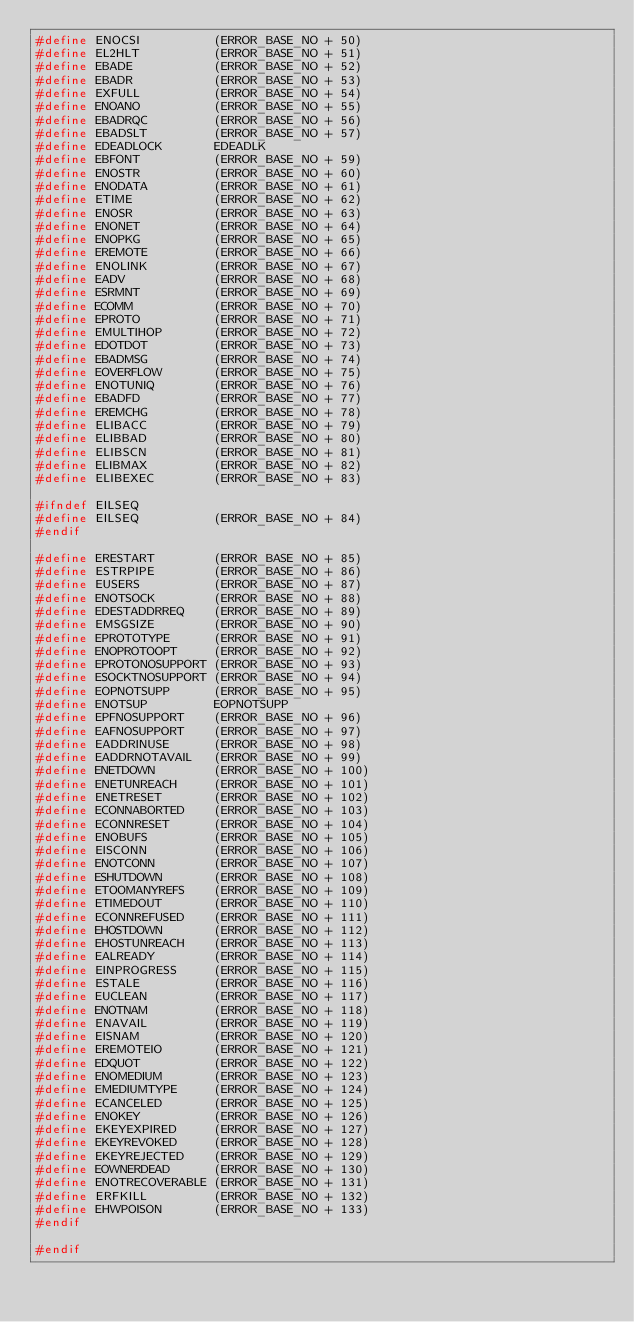<code> <loc_0><loc_0><loc_500><loc_500><_C_>#define ENOCSI          (ERROR_BASE_NO + 50)
#define EL2HLT          (ERROR_BASE_NO + 51)
#define EBADE           (ERROR_BASE_NO + 52)
#define EBADR           (ERROR_BASE_NO + 53)
#define EXFULL          (ERROR_BASE_NO + 54)
#define ENOANO          (ERROR_BASE_NO + 55)
#define EBADRQC         (ERROR_BASE_NO + 56)
#define EBADSLT         (ERROR_BASE_NO + 57)
#define EDEADLOCK       EDEADLK
#define EBFONT          (ERROR_BASE_NO + 59)
#define ENOSTR          (ERROR_BASE_NO + 60)
#define ENODATA         (ERROR_BASE_NO + 61)
#define ETIME           (ERROR_BASE_NO + 62)
#define ENOSR           (ERROR_BASE_NO + 63)
#define ENONET          (ERROR_BASE_NO + 64)
#define ENOPKG          (ERROR_BASE_NO + 65)
#define EREMOTE         (ERROR_BASE_NO + 66)
#define ENOLINK         (ERROR_BASE_NO + 67)
#define EADV            (ERROR_BASE_NO + 68)
#define ESRMNT          (ERROR_BASE_NO + 69)
#define ECOMM           (ERROR_BASE_NO + 70)
#define EPROTO          (ERROR_BASE_NO + 71)
#define EMULTIHOP       (ERROR_BASE_NO + 72)
#define EDOTDOT         (ERROR_BASE_NO + 73)
#define EBADMSG         (ERROR_BASE_NO + 74)
#define EOVERFLOW       (ERROR_BASE_NO + 75)
#define ENOTUNIQ        (ERROR_BASE_NO + 76)
#define EBADFD          (ERROR_BASE_NO + 77)
#define EREMCHG         (ERROR_BASE_NO + 78)
#define ELIBACC         (ERROR_BASE_NO + 79)
#define ELIBBAD         (ERROR_BASE_NO + 80)
#define ELIBSCN         (ERROR_BASE_NO + 81)
#define ELIBMAX         (ERROR_BASE_NO + 82)
#define ELIBEXEC        (ERROR_BASE_NO + 83)

#ifndef EILSEQ
#define EILSEQ          (ERROR_BASE_NO + 84)
#endif

#define ERESTART        (ERROR_BASE_NO + 85)
#define ESTRPIPE        (ERROR_BASE_NO + 86)
#define EUSERS          (ERROR_BASE_NO + 87)
#define ENOTSOCK        (ERROR_BASE_NO + 88)
#define EDESTADDRREQ    (ERROR_BASE_NO + 89)
#define EMSGSIZE        (ERROR_BASE_NO + 90)
#define EPROTOTYPE      (ERROR_BASE_NO + 91)
#define ENOPROTOOPT     (ERROR_BASE_NO + 92)
#define EPROTONOSUPPORT (ERROR_BASE_NO + 93)
#define ESOCKTNOSUPPORT (ERROR_BASE_NO + 94)
#define EOPNOTSUPP      (ERROR_BASE_NO + 95)
#define ENOTSUP         EOPNOTSUPP
#define EPFNOSUPPORT    (ERROR_BASE_NO + 96)
#define EAFNOSUPPORT    (ERROR_BASE_NO + 97)
#define EADDRINUSE      (ERROR_BASE_NO + 98)
#define EADDRNOTAVAIL   (ERROR_BASE_NO + 99)
#define ENETDOWN        (ERROR_BASE_NO + 100)
#define ENETUNREACH     (ERROR_BASE_NO + 101)
#define ENETRESET       (ERROR_BASE_NO + 102)
#define ECONNABORTED    (ERROR_BASE_NO + 103)
#define ECONNRESET      (ERROR_BASE_NO + 104)
#define ENOBUFS         (ERROR_BASE_NO + 105)
#define EISCONN         (ERROR_BASE_NO + 106)
#define ENOTCONN        (ERROR_BASE_NO + 107)
#define ESHUTDOWN       (ERROR_BASE_NO + 108)
#define ETOOMANYREFS    (ERROR_BASE_NO + 109)
#define ETIMEDOUT       (ERROR_BASE_NO + 110)
#define ECONNREFUSED    (ERROR_BASE_NO + 111)
#define EHOSTDOWN       (ERROR_BASE_NO + 112)
#define EHOSTUNREACH    (ERROR_BASE_NO + 113)
#define EALREADY        (ERROR_BASE_NO + 114)
#define EINPROGRESS     (ERROR_BASE_NO + 115)
#define ESTALE          (ERROR_BASE_NO + 116)
#define EUCLEAN         (ERROR_BASE_NO + 117)
#define ENOTNAM         (ERROR_BASE_NO + 118)
#define ENAVAIL         (ERROR_BASE_NO + 119)
#define EISNAM          (ERROR_BASE_NO + 120)
#define EREMOTEIO       (ERROR_BASE_NO + 121)
#define EDQUOT          (ERROR_BASE_NO + 122)
#define ENOMEDIUM       (ERROR_BASE_NO + 123)
#define EMEDIUMTYPE     (ERROR_BASE_NO + 124)
#define ECANCELED       (ERROR_BASE_NO + 125)
#define ENOKEY          (ERROR_BASE_NO + 126)
#define EKEYEXPIRED     (ERROR_BASE_NO + 127)
#define EKEYREVOKED     (ERROR_BASE_NO + 128)
#define EKEYREJECTED    (ERROR_BASE_NO + 129)
#define EOWNERDEAD      (ERROR_BASE_NO + 130)
#define ENOTRECOVERABLE (ERROR_BASE_NO + 131)
#define ERFKILL         (ERROR_BASE_NO + 132)
#define EHWPOISON       (ERROR_BASE_NO + 133)
#endif

#endif
</code> 